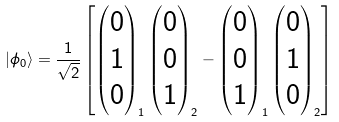<formula> <loc_0><loc_0><loc_500><loc_500>\left | \phi _ { 0 } \right > = \frac { 1 } { \sqrt { 2 } } \left [ \begin{pmatrix} 0 \\ 1 \\ 0 \end{pmatrix} _ { 1 } \begin{pmatrix} 0 \\ 0 \\ 1 \end{pmatrix} _ { 2 } - \begin{pmatrix} 0 \\ 0 \\ 1 \end{pmatrix} _ { 1 } \begin{pmatrix} 0 \\ 1 \\ 0 \end{pmatrix} _ { 2 } \right ]</formula> 